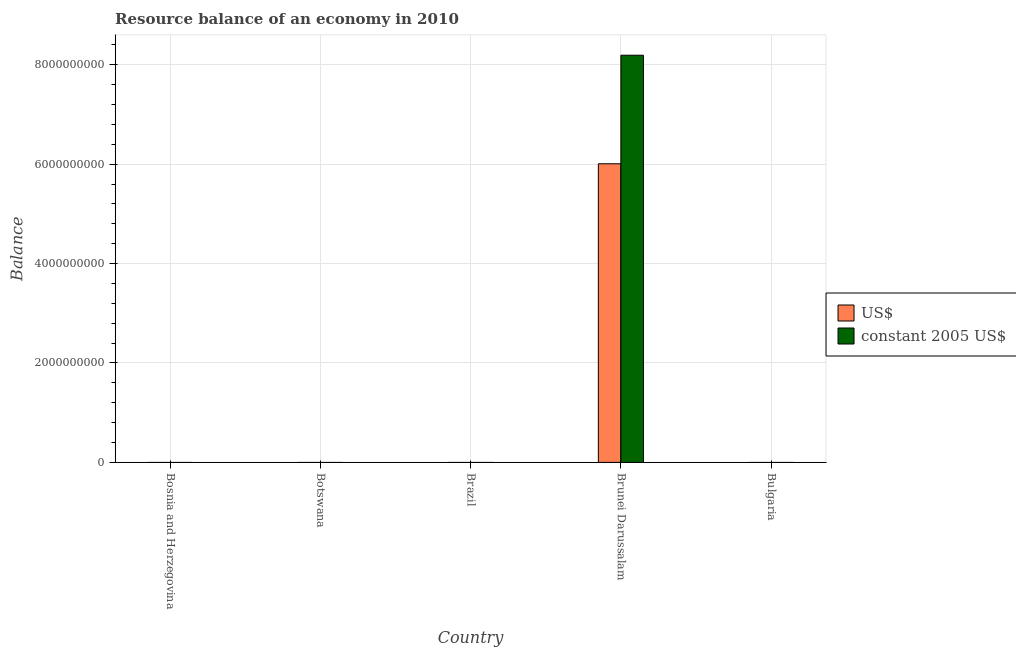Are the number of bars per tick equal to the number of legend labels?
Make the answer very short. No. How many bars are there on the 4th tick from the left?
Offer a terse response. 2. What is the label of the 4th group of bars from the left?
Provide a short and direct response. Brunei Darussalam. Across all countries, what is the maximum resource balance in constant us$?
Your response must be concise. 8.19e+09. Across all countries, what is the minimum resource balance in constant us$?
Your answer should be very brief. 0. In which country was the resource balance in constant us$ maximum?
Keep it short and to the point. Brunei Darussalam. What is the total resource balance in us$ in the graph?
Make the answer very short. 6.01e+09. What is the average resource balance in constant us$ per country?
Your response must be concise. 1.64e+09. What is the difference between the resource balance in constant us$ and resource balance in us$ in Brunei Darussalam?
Keep it short and to the point. 2.18e+09. What is the difference between the highest and the lowest resource balance in constant us$?
Give a very brief answer. 8.19e+09. How many bars are there?
Provide a short and direct response. 2. Are all the bars in the graph horizontal?
Make the answer very short. No. Are the values on the major ticks of Y-axis written in scientific E-notation?
Provide a short and direct response. No. Does the graph contain grids?
Provide a succinct answer. Yes. Where does the legend appear in the graph?
Ensure brevity in your answer.  Center right. How many legend labels are there?
Your answer should be very brief. 2. How are the legend labels stacked?
Your answer should be compact. Vertical. What is the title of the graph?
Provide a succinct answer. Resource balance of an economy in 2010. Does "Food and tobacco" appear as one of the legend labels in the graph?
Keep it short and to the point. No. What is the label or title of the Y-axis?
Give a very brief answer. Balance. What is the Balance of US$ in Bosnia and Herzegovina?
Offer a very short reply. 0. What is the Balance in US$ in Botswana?
Your answer should be compact. 0. What is the Balance in constant 2005 US$ in Botswana?
Provide a succinct answer. 0. What is the Balance of constant 2005 US$ in Brazil?
Your answer should be very brief. 0. What is the Balance in US$ in Brunei Darussalam?
Offer a terse response. 6.01e+09. What is the Balance of constant 2005 US$ in Brunei Darussalam?
Provide a short and direct response. 8.19e+09. What is the Balance of US$ in Bulgaria?
Your response must be concise. 0. Across all countries, what is the maximum Balance of US$?
Keep it short and to the point. 6.01e+09. Across all countries, what is the maximum Balance of constant 2005 US$?
Offer a terse response. 8.19e+09. Across all countries, what is the minimum Balance of US$?
Offer a very short reply. 0. Across all countries, what is the minimum Balance in constant 2005 US$?
Provide a short and direct response. 0. What is the total Balance in US$ in the graph?
Offer a terse response. 6.01e+09. What is the total Balance of constant 2005 US$ in the graph?
Ensure brevity in your answer.  8.19e+09. What is the average Balance in US$ per country?
Give a very brief answer. 1.20e+09. What is the average Balance in constant 2005 US$ per country?
Offer a terse response. 1.64e+09. What is the difference between the Balance of US$ and Balance of constant 2005 US$ in Brunei Darussalam?
Ensure brevity in your answer.  -2.18e+09. What is the difference between the highest and the lowest Balance in US$?
Make the answer very short. 6.01e+09. What is the difference between the highest and the lowest Balance of constant 2005 US$?
Give a very brief answer. 8.19e+09. 